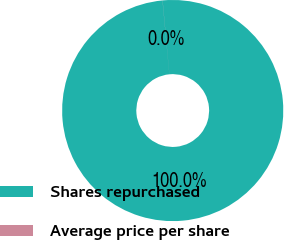<chart> <loc_0><loc_0><loc_500><loc_500><pie_chart><fcel>Shares repurchased<fcel>Average price per share<nl><fcel>99.99%<fcel>0.01%<nl></chart> 